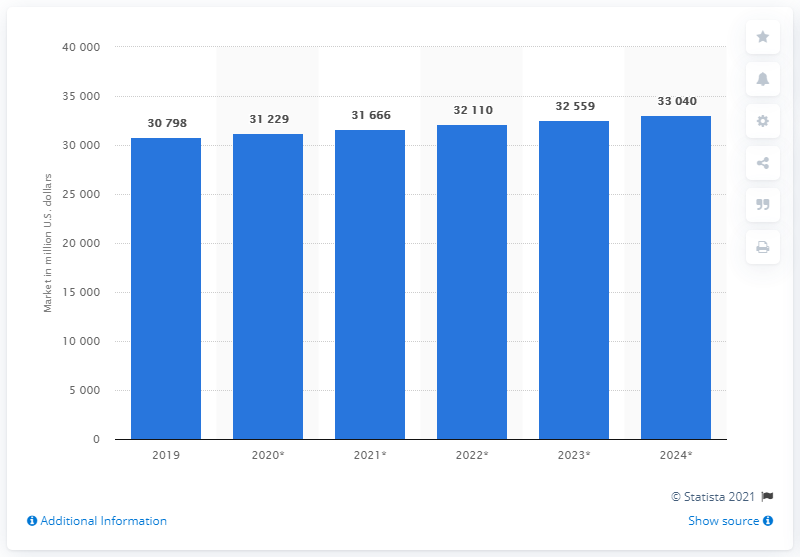Give some essential details in this illustration. In 2019, the global market for Human Capital Management (HCM) applications was worth approximately 30,798 million dollars. 